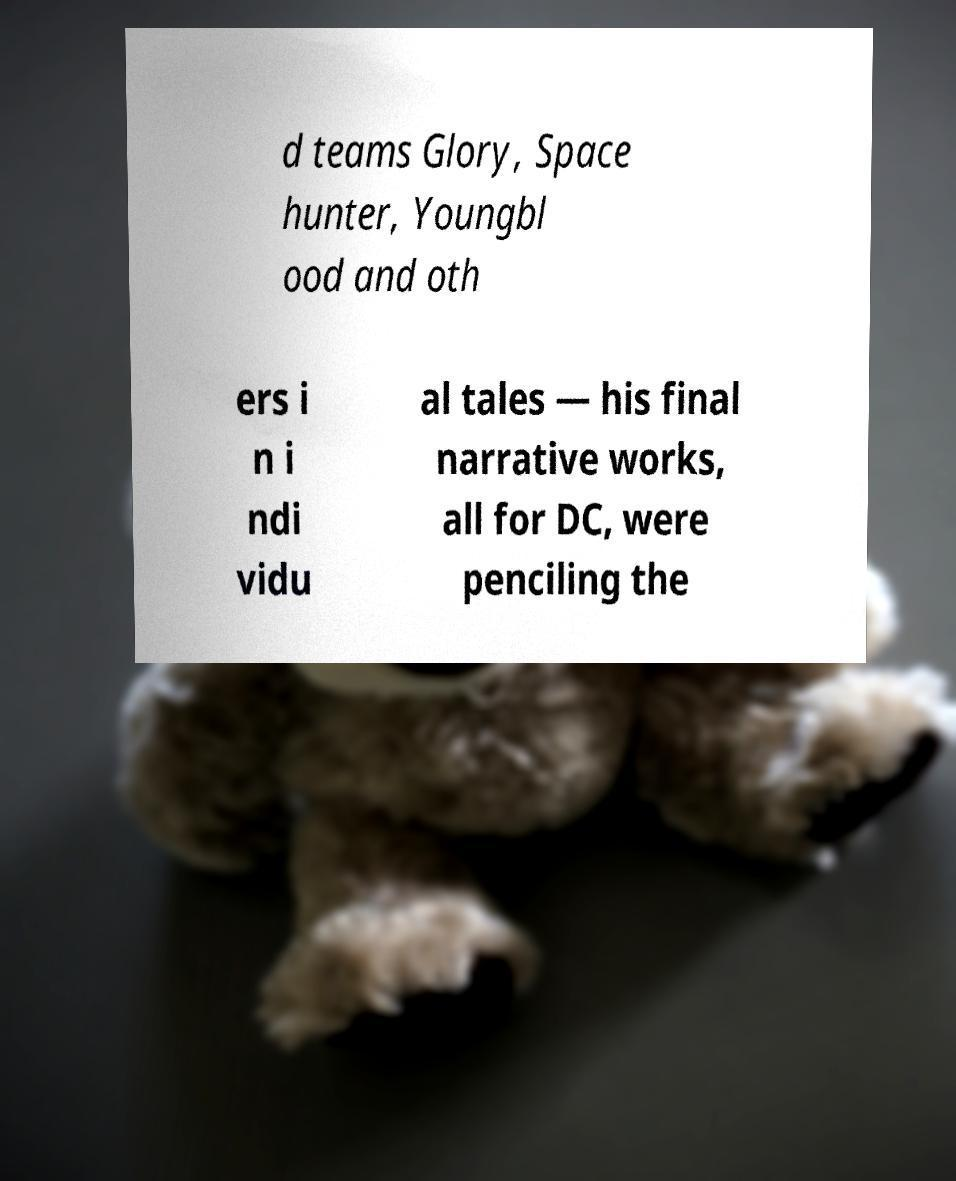Can you read and provide the text displayed in the image?This photo seems to have some interesting text. Can you extract and type it out for me? d teams Glory, Space hunter, Youngbl ood and oth ers i n i ndi vidu al tales — his final narrative works, all for DC, were penciling the 